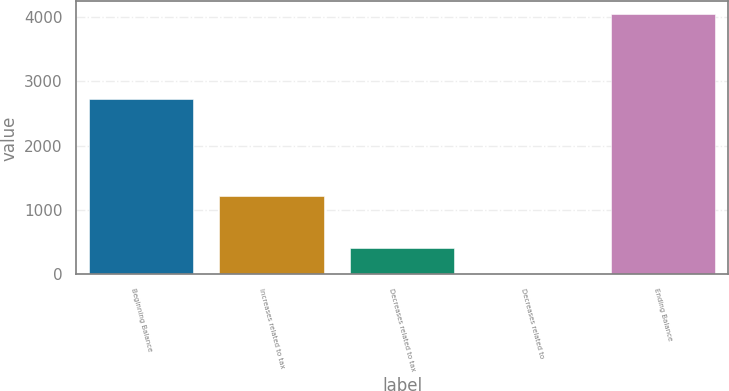<chart> <loc_0><loc_0><loc_500><loc_500><bar_chart><fcel>Beginning Balance<fcel>Increases related to tax<fcel>Decreases related to tax<fcel>Decreases related to<fcel>Ending Balance<nl><fcel>2714<fcel>1212.7<fcel>406.9<fcel>4<fcel>4033<nl></chart> 